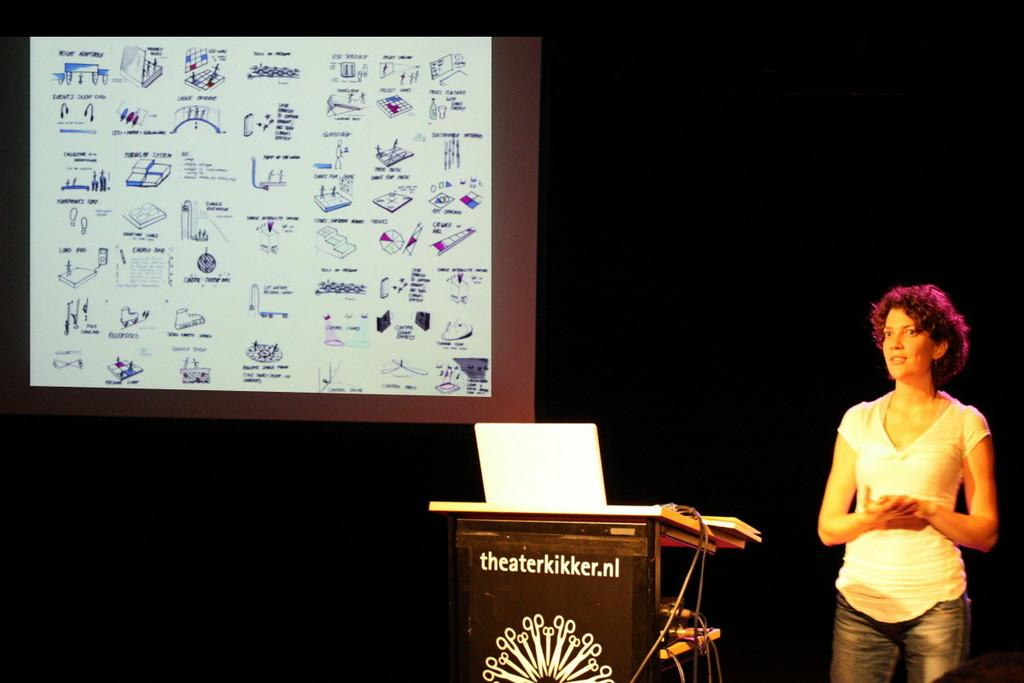Who is present on the right side of the image? There is a woman standing on the right side of the image. What can be seen in the image besides the woman? There is a podium, objects, wires, and a screen visible in the image. What might the podium be used for? The podium could be used for speaking or presenting information. What is the lighting condition in the image? The overall view of the image appears to be dark. What type of creature is providing advice to the woman in the image? There is no creature present in the image, and therefore no advice-giving creature can be observed. 